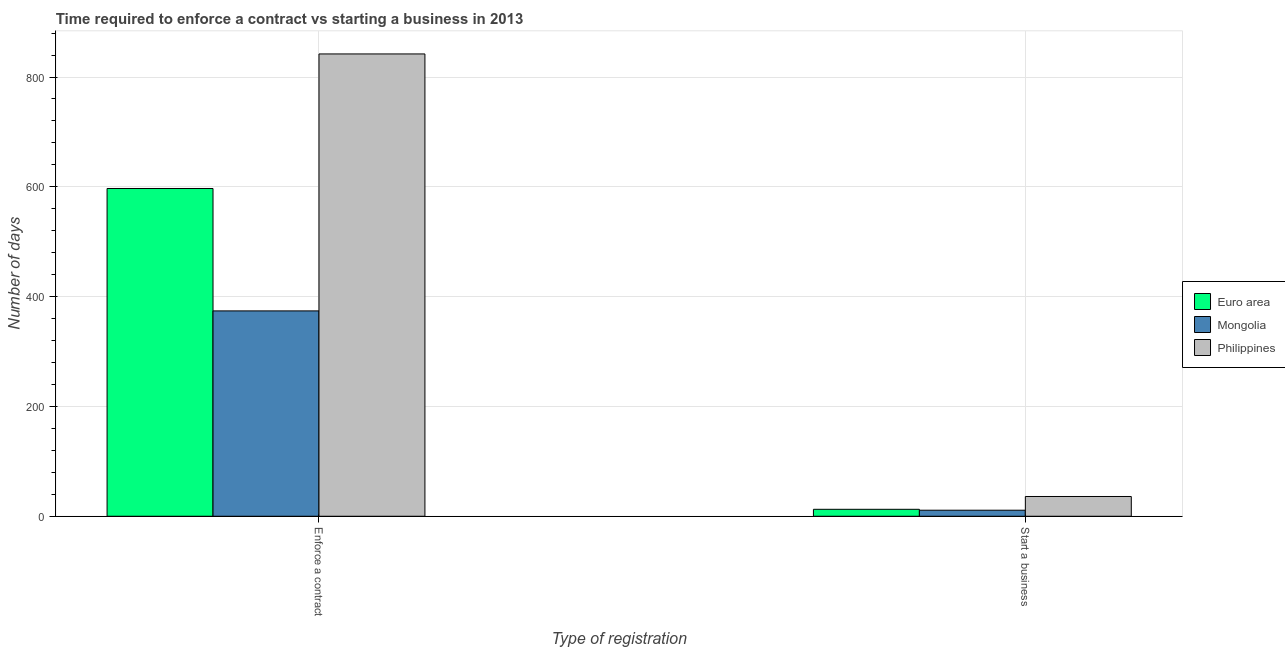How many groups of bars are there?
Your answer should be compact. 2. Are the number of bars per tick equal to the number of legend labels?
Keep it short and to the point. Yes. What is the label of the 1st group of bars from the left?
Your response must be concise. Enforce a contract. What is the number of days to start a business in Euro area?
Offer a very short reply. 12.66. Across all countries, what is the maximum number of days to enforece a contract?
Your answer should be compact. 842. In which country was the number of days to enforece a contract maximum?
Offer a very short reply. Philippines. In which country was the number of days to start a business minimum?
Offer a terse response. Mongolia. What is the total number of days to start a business in the graph?
Make the answer very short. 59.66. What is the difference between the number of days to start a business in Mongolia and that in Euro area?
Provide a short and direct response. -1.66. What is the difference between the number of days to start a business in Philippines and the number of days to enforece a contract in Euro area?
Ensure brevity in your answer.  -560.95. What is the average number of days to enforece a contract per country?
Ensure brevity in your answer.  604.32. What is the difference between the number of days to enforece a contract and number of days to start a business in Mongolia?
Provide a short and direct response. 363. What is the ratio of the number of days to start a business in Philippines to that in Euro area?
Ensure brevity in your answer.  2.84. What does the 2nd bar from the left in Start a business represents?
Provide a short and direct response. Mongolia. Are all the bars in the graph horizontal?
Keep it short and to the point. No. What is the difference between two consecutive major ticks on the Y-axis?
Offer a terse response. 200. Does the graph contain any zero values?
Ensure brevity in your answer.  No. Where does the legend appear in the graph?
Your answer should be very brief. Center right. How many legend labels are there?
Your answer should be compact. 3. What is the title of the graph?
Provide a short and direct response. Time required to enforce a contract vs starting a business in 2013. Does "Brazil" appear as one of the legend labels in the graph?
Your answer should be compact. No. What is the label or title of the X-axis?
Your response must be concise. Type of registration. What is the label or title of the Y-axis?
Provide a succinct answer. Number of days. What is the Number of days of Euro area in Enforce a contract?
Offer a very short reply. 596.95. What is the Number of days of Mongolia in Enforce a contract?
Offer a very short reply. 374. What is the Number of days of Philippines in Enforce a contract?
Offer a terse response. 842. What is the Number of days in Euro area in Start a business?
Your response must be concise. 12.66. Across all Type of registration, what is the maximum Number of days of Euro area?
Make the answer very short. 596.95. Across all Type of registration, what is the maximum Number of days in Mongolia?
Ensure brevity in your answer.  374. Across all Type of registration, what is the maximum Number of days of Philippines?
Your response must be concise. 842. Across all Type of registration, what is the minimum Number of days in Euro area?
Your answer should be compact. 12.66. Across all Type of registration, what is the minimum Number of days of Mongolia?
Offer a very short reply. 11. What is the total Number of days in Euro area in the graph?
Your answer should be very brief. 609.61. What is the total Number of days of Mongolia in the graph?
Your answer should be very brief. 385. What is the total Number of days of Philippines in the graph?
Offer a very short reply. 878. What is the difference between the Number of days of Euro area in Enforce a contract and that in Start a business?
Offer a very short reply. 584.29. What is the difference between the Number of days of Mongolia in Enforce a contract and that in Start a business?
Offer a very short reply. 363. What is the difference between the Number of days of Philippines in Enforce a contract and that in Start a business?
Your response must be concise. 806. What is the difference between the Number of days in Euro area in Enforce a contract and the Number of days in Mongolia in Start a business?
Provide a short and direct response. 585.95. What is the difference between the Number of days in Euro area in Enforce a contract and the Number of days in Philippines in Start a business?
Your answer should be very brief. 560.95. What is the difference between the Number of days of Mongolia in Enforce a contract and the Number of days of Philippines in Start a business?
Keep it short and to the point. 338. What is the average Number of days of Euro area per Type of registration?
Provide a short and direct response. 304.8. What is the average Number of days of Mongolia per Type of registration?
Your response must be concise. 192.5. What is the average Number of days in Philippines per Type of registration?
Your answer should be very brief. 439. What is the difference between the Number of days of Euro area and Number of days of Mongolia in Enforce a contract?
Provide a succinct answer. 222.95. What is the difference between the Number of days of Euro area and Number of days of Philippines in Enforce a contract?
Your response must be concise. -245.05. What is the difference between the Number of days in Mongolia and Number of days in Philippines in Enforce a contract?
Give a very brief answer. -468. What is the difference between the Number of days in Euro area and Number of days in Mongolia in Start a business?
Ensure brevity in your answer.  1.66. What is the difference between the Number of days in Euro area and Number of days in Philippines in Start a business?
Make the answer very short. -23.34. What is the ratio of the Number of days in Euro area in Enforce a contract to that in Start a business?
Provide a succinct answer. 47.16. What is the ratio of the Number of days in Philippines in Enforce a contract to that in Start a business?
Keep it short and to the point. 23.39. What is the difference between the highest and the second highest Number of days in Euro area?
Make the answer very short. 584.29. What is the difference between the highest and the second highest Number of days of Mongolia?
Your response must be concise. 363. What is the difference between the highest and the second highest Number of days in Philippines?
Ensure brevity in your answer.  806. What is the difference between the highest and the lowest Number of days of Euro area?
Your response must be concise. 584.29. What is the difference between the highest and the lowest Number of days of Mongolia?
Offer a terse response. 363. What is the difference between the highest and the lowest Number of days of Philippines?
Provide a succinct answer. 806. 